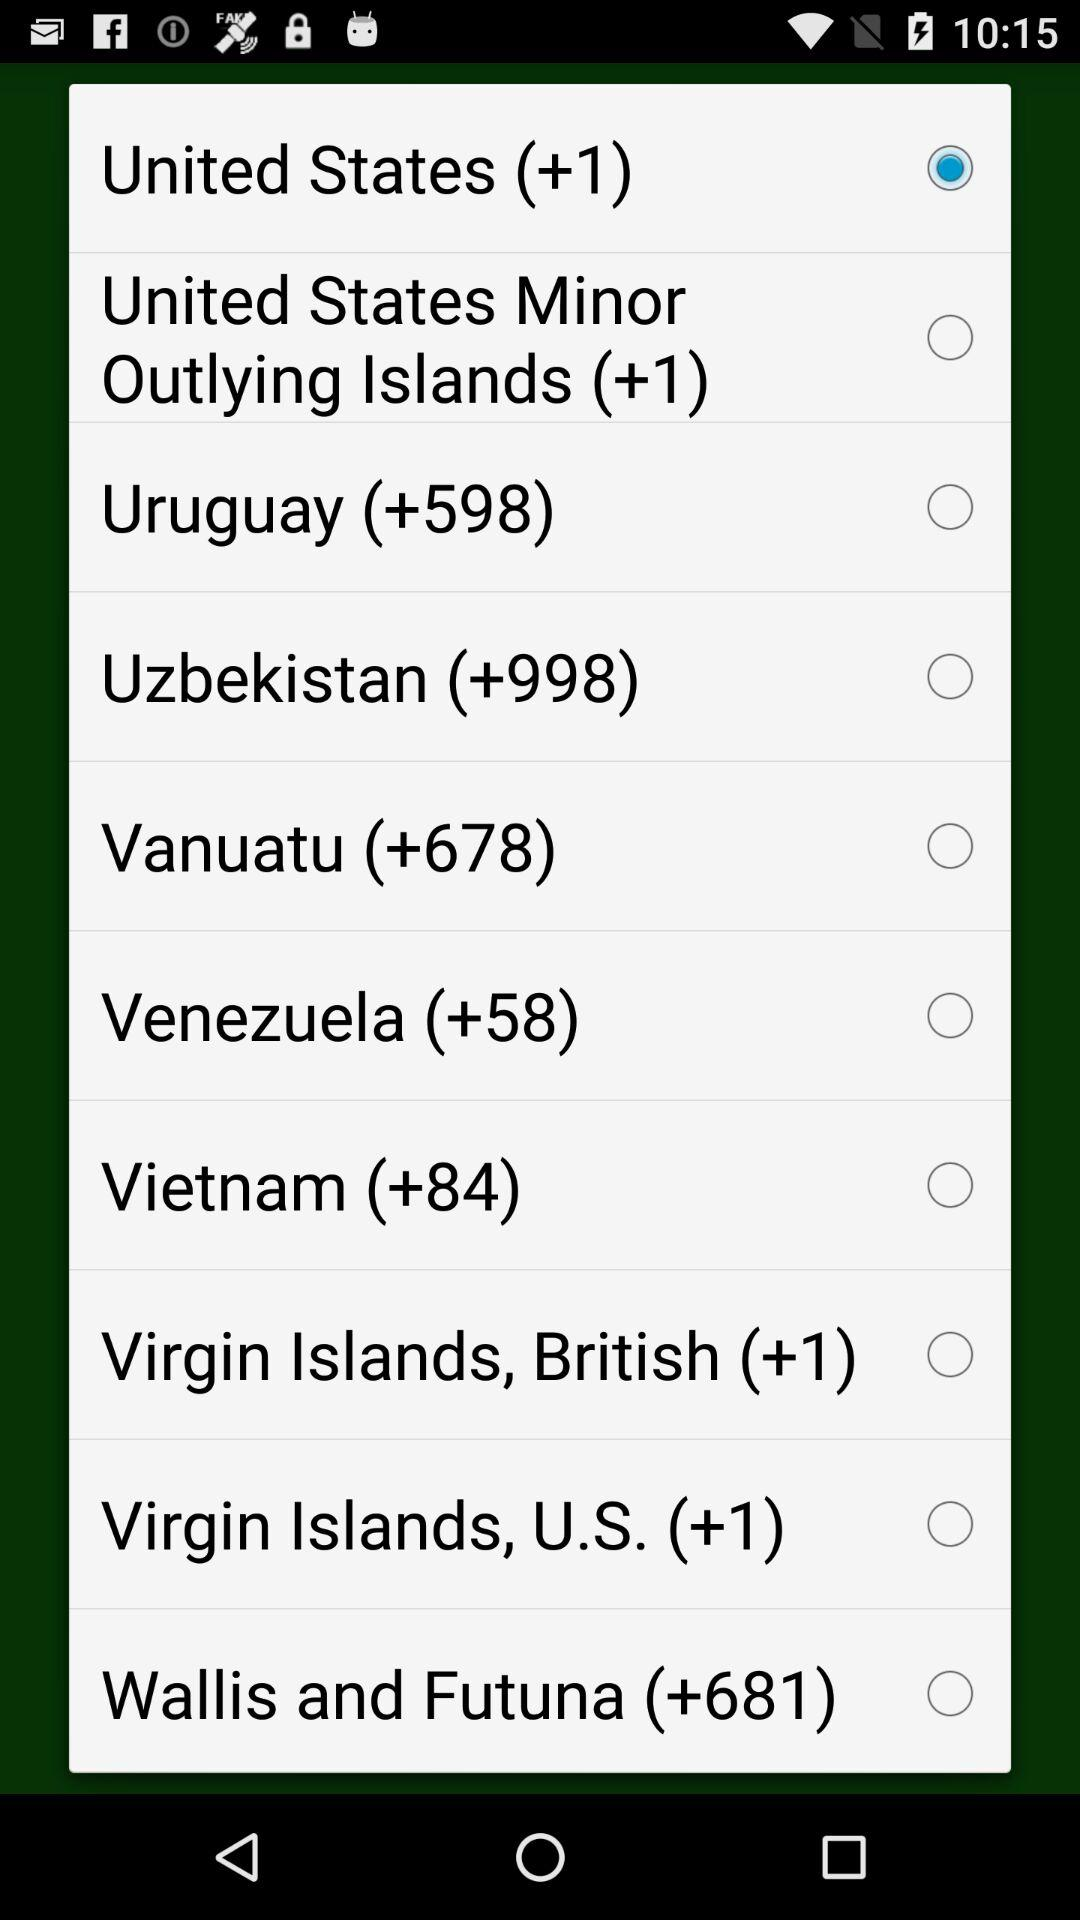What is the country code of Vietnam? The country code of Vietnam is +84. 